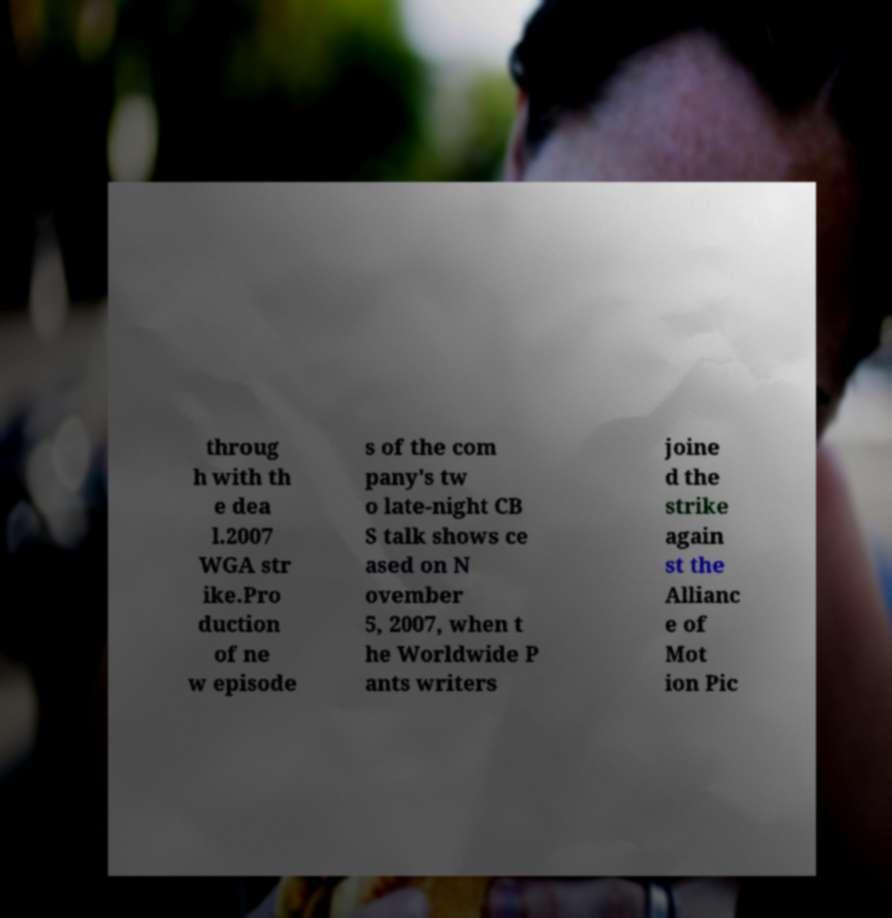Please read and relay the text visible in this image. What does it say? throug h with th e dea l.2007 WGA str ike.Pro duction of ne w episode s of the com pany's tw o late-night CB S talk shows ce ased on N ovember 5, 2007, when t he Worldwide P ants writers joine d the strike again st the Allianc e of Mot ion Pic 